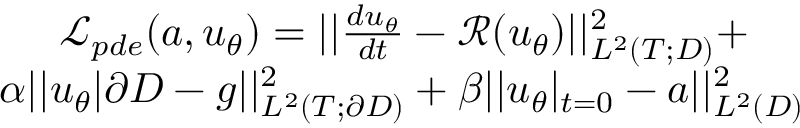<formula> <loc_0><loc_0><loc_500><loc_500>\begin{array} { r } { \mathcal { L } _ { p d e } ( a , u _ { \theta } ) = | | \frac { d u _ { \theta } } { d t } - \mathcal { R } ( u _ { \theta } ) | | _ { L ^ { 2 } ( T ; D ) } ^ { 2 } + } \\ { \alpha | | u _ { \theta } | \partial D - g | | _ { L ^ { 2 } ( T ; \partial D ) } ^ { 2 } + \beta | | u _ { \theta } | _ { t = 0 } - a | | _ { L ^ { 2 } ( D ) } ^ { 2 } } \end{array}</formula> 